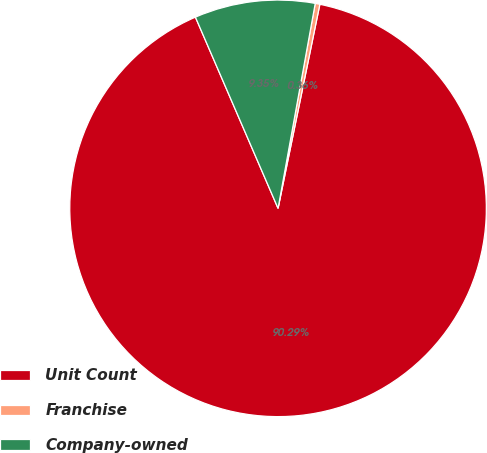<chart> <loc_0><loc_0><loc_500><loc_500><pie_chart><fcel>Unit Count<fcel>Franchise<fcel>Company-owned<nl><fcel>90.29%<fcel>0.36%<fcel>9.35%<nl></chart> 